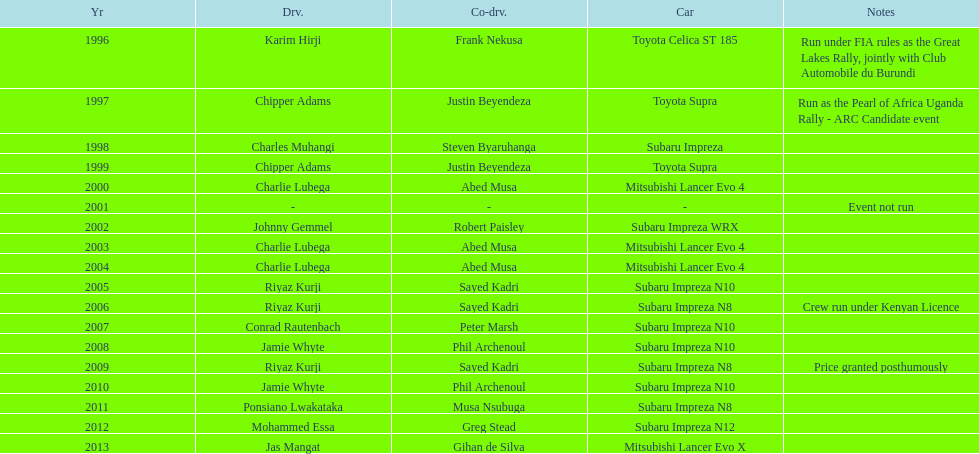How many occasions did charlie lubega serve as a driver? 3. 